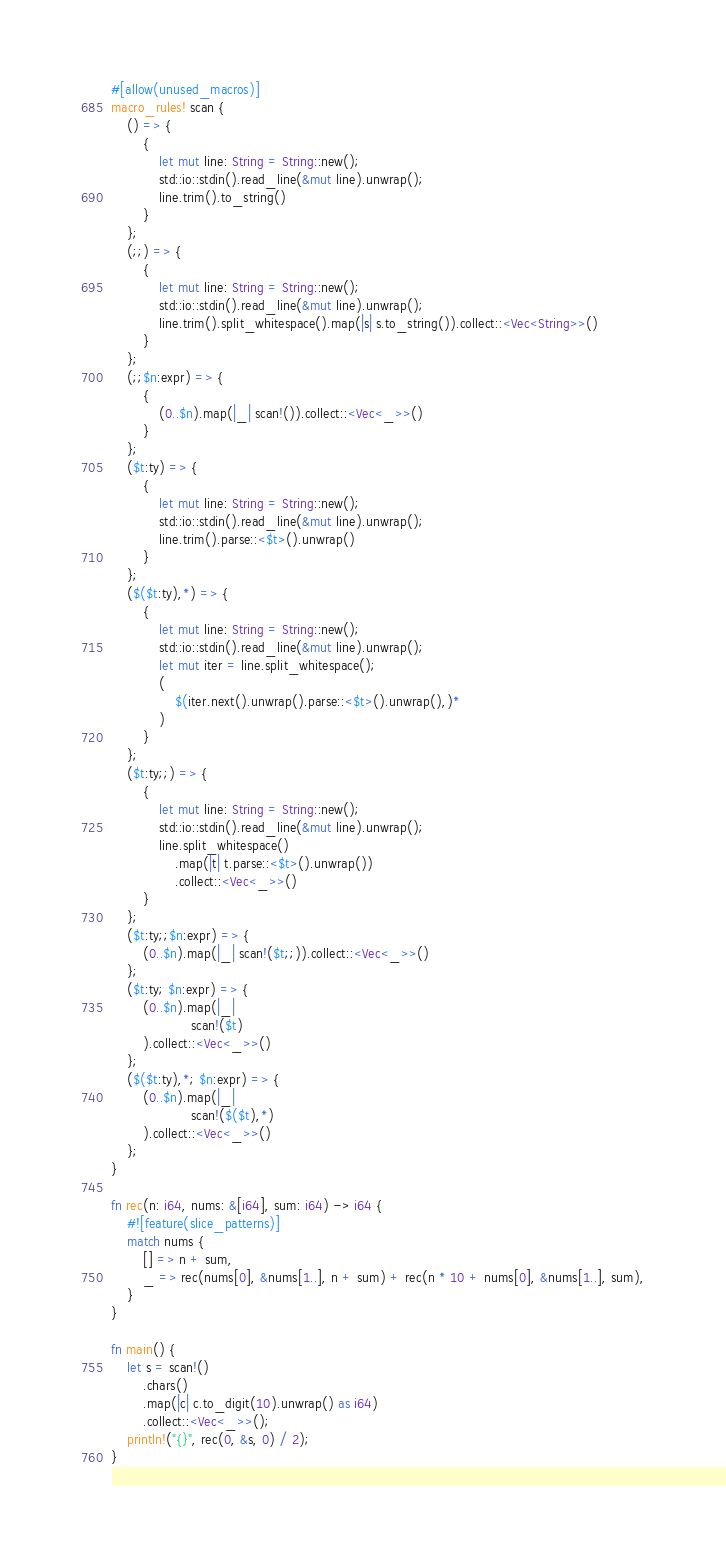<code> <loc_0><loc_0><loc_500><loc_500><_Rust_>#[allow(unused_macros)]
macro_rules! scan {
    () => {
        {
            let mut line: String = String::new();
            std::io::stdin().read_line(&mut line).unwrap();
            line.trim().to_string()
        }
    };
    (;;) => {
        {
            let mut line: String = String::new();
            std::io::stdin().read_line(&mut line).unwrap();
            line.trim().split_whitespace().map(|s| s.to_string()).collect::<Vec<String>>()
        }
    };
    (;;$n:expr) => {
        {
            (0..$n).map(|_| scan!()).collect::<Vec<_>>()
        }
    };
    ($t:ty) => {
        {
            let mut line: String = String::new();
            std::io::stdin().read_line(&mut line).unwrap();
            line.trim().parse::<$t>().unwrap()
        }
    };
    ($($t:ty),*) => {
        {
            let mut line: String = String::new();
            std::io::stdin().read_line(&mut line).unwrap();
            let mut iter = line.split_whitespace();
            (
                $(iter.next().unwrap().parse::<$t>().unwrap(),)*
            )
        }
    };
    ($t:ty;;) => {
        {
            let mut line: String = String::new();
            std::io::stdin().read_line(&mut line).unwrap();
            line.split_whitespace()
                .map(|t| t.parse::<$t>().unwrap())
                .collect::<Vec<_>>()
        }
    };
    ($t:ty;;$n:expr) => {
        (0..$n).map(|_| scan!($t;;)).collect::<Vec<_>>()
    };
    ($t:ty; $n:expr) => {
        (0..$n).map(|_|
                    scan!($t)
        ).collect::<Vec<_>>()
    };
    ($($t:ty),*; $n:expr) => {
        (0..$n).map(|_|
                    scan!($($t),*)
        ).collect::<Vec<_>>()
    };
}

fn rec(n: i64, nums: &[i64], sum: i64) -> i64 {
    #![feature(slice_patterns)]
    match nums {
        [] => n + sum,
        _ => rec(nums[0], &nums[1..], n + sum) + rec(n * 10 + nums[0], &nums[1..], sum),
    }
}

fn main() {
    let s = scan!()
        .chars()
        .map(|c| c.to_digit(10).unwrap() as i64)
        .collect::<Vec<_>>();
    println!("{}", rec(0, &s, 0) / 2);
}
</code> 